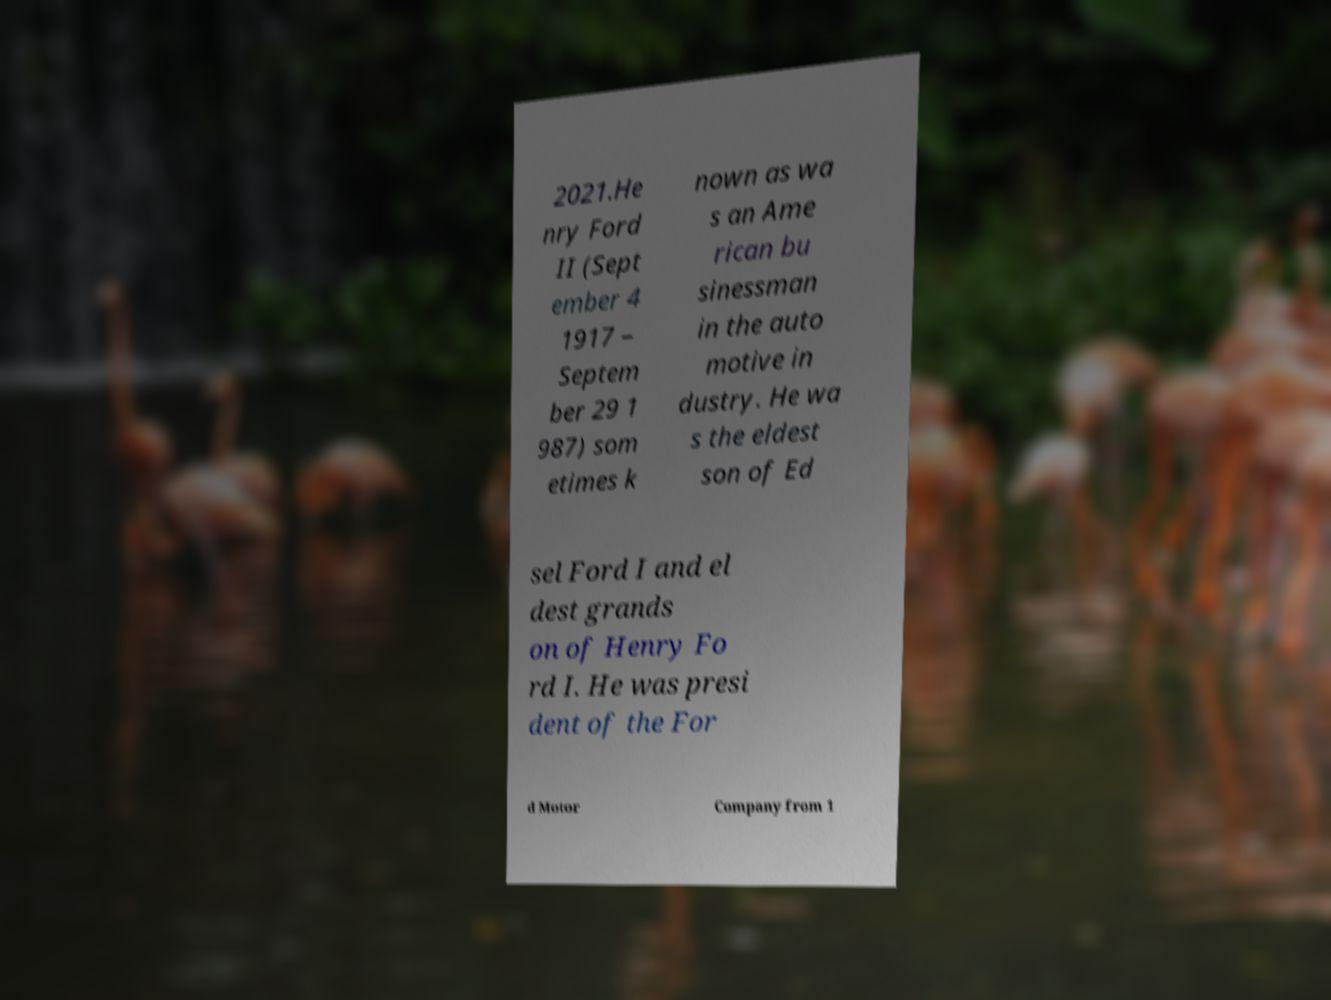There's text embedded in this image that I need extracted. Can you transcribe it verbatim? 2021.He nry Ford II (Sept ember 4 1917 – Septem ber 29 1 987) som etimes k nown as wa s an Ame rican bu sinessman in the auto motive in dustry. He wa s the eldest son of Ed sel Ford I and el dest grands on of Henry Fo rd I. He was presi dent of the For d Motor Company from 1 